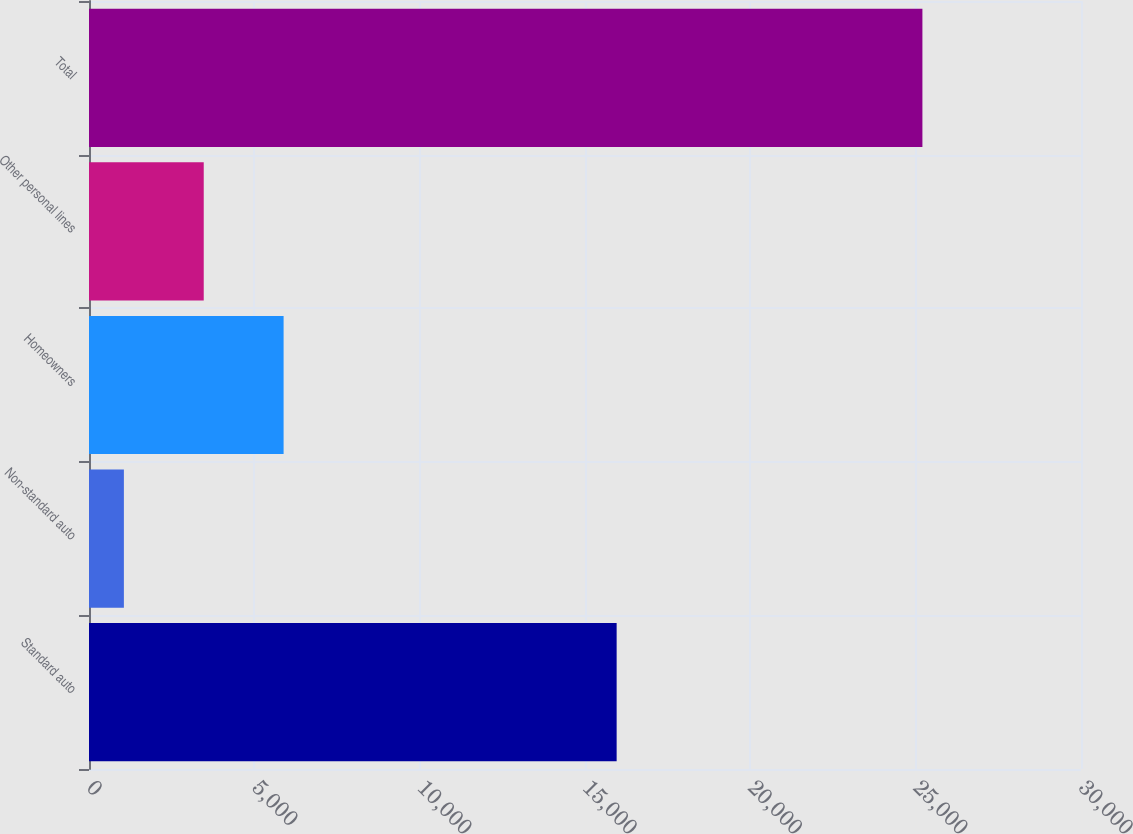<chart> <loc_0><loc_0><loc_500><loc_500><bar_chart><fcel>Standard auto<fcel>Non-standard auto<fcel>Homeowners<fcel>Other personal lines<fcel>Total<nl><fcel>15957<fcel>1055<fcel>5884.8<fcel>3469.9<fcel>25204<nl></chart> 